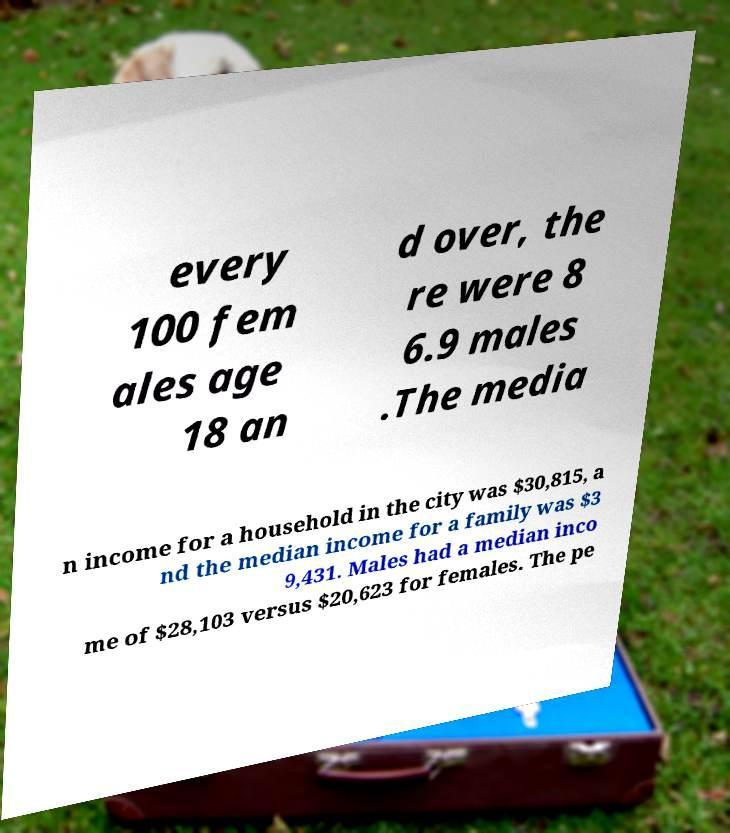Could you assist in decoding the text presented in this image and type it out clearly? every 100 fem ales age 18 an d over, the re were 8 6.9 males .The media n income for a household in the city was $30,815, a nd the median income for a family was $3 9,431. Males had a median inco me of $28,103 versus $20,623 for females. The pe 